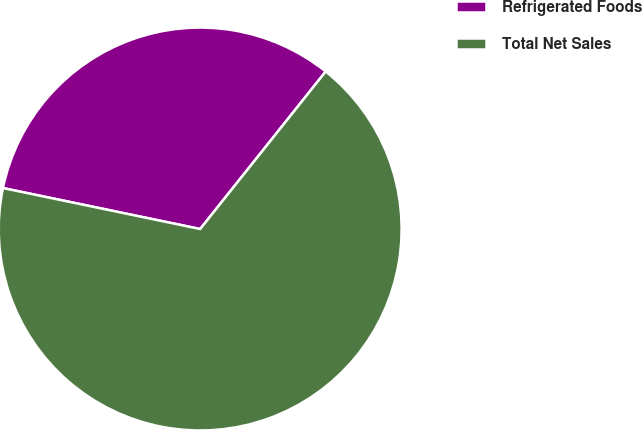Convert chart. <chart><loc_0><loc_0><loc_500><loc_500><pie_chart><fcel>Refrigerated Foods<fcel>Total Net Sales<nl><fcel>32.45%<fcel>67.55%<nl></chart> 